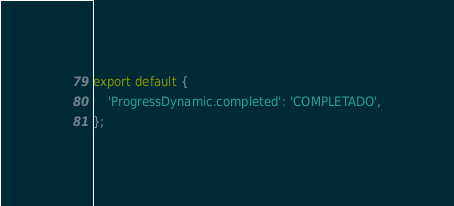Convert code to text. <code><loc_0><loc_0><loc_500><loc_500><_TypeScript_>export default {
    'ProgressDynamic.completed': 'COMPLETADO',
};
</code> 